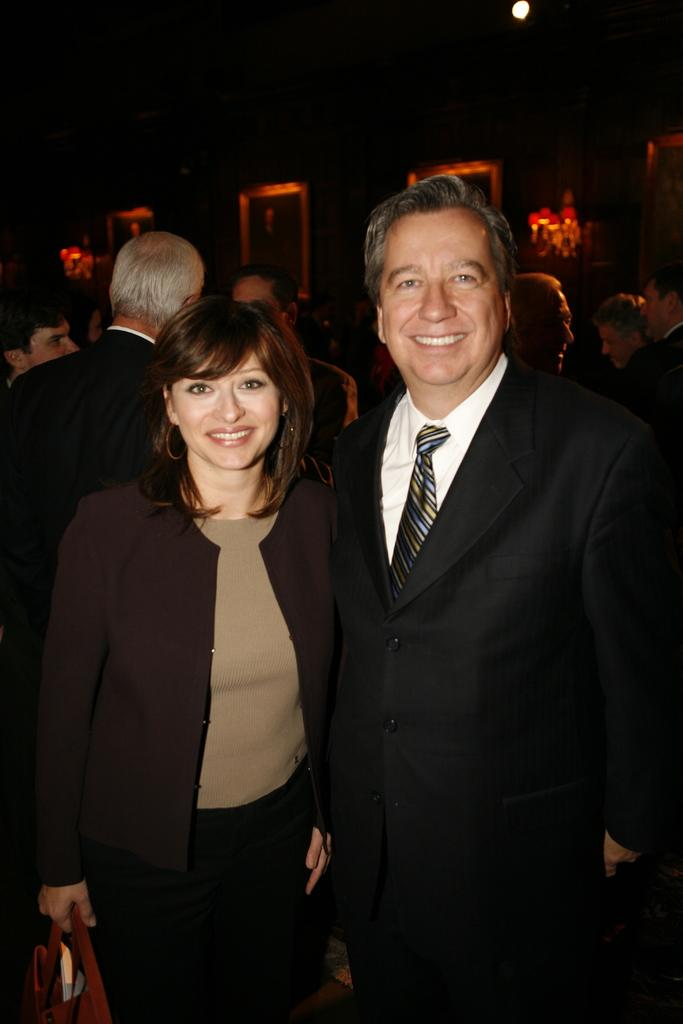What is happening in the image? There are people standing in the image. Can you describe the expressions of the people in the front? Two persons in the front are smiling. What can be seen in the background of the image? There are photo frames in the background of the image. What is the source of light in the image? There is a light visible in the image. Can you tell me how many matches are being held by the people in the image? There are no matches visible in the image; the people are not holding any. 